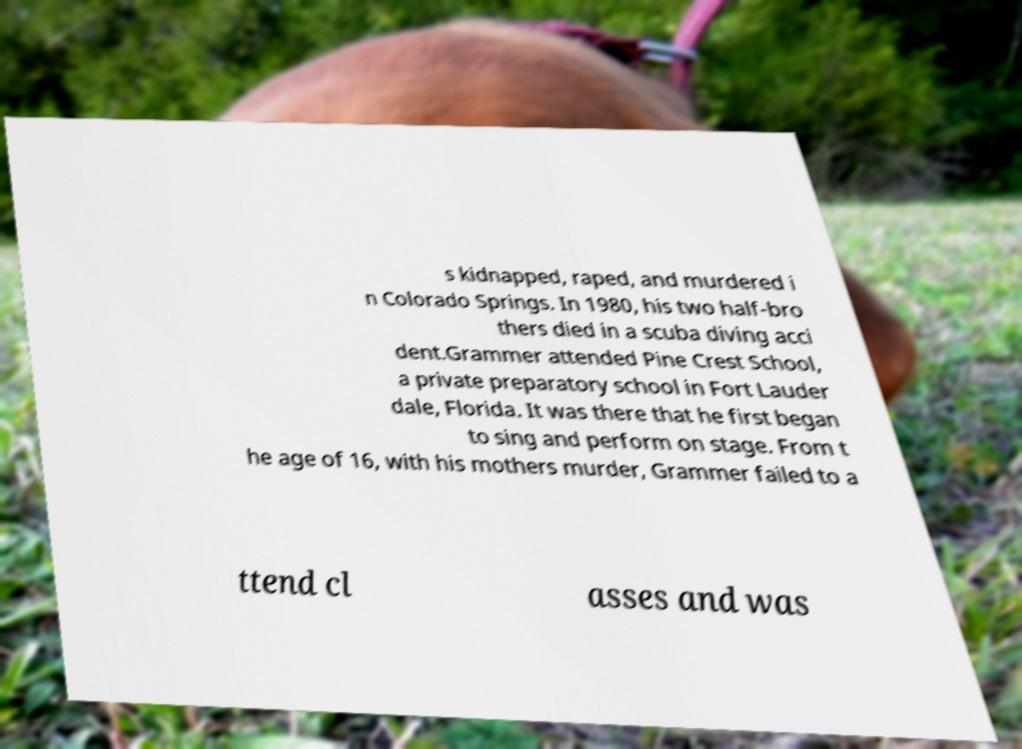There's text embedded in this image that I need extracted. Can you transcribe it verbatim? s kidnapped, raped, and murdered i n Colorado Springs. In 1980, his two half-bro thers died in a scuba diving acci dent.Grammer attended Pine Crest School, a private preparatory school in Fort Lauder dale, Florida. It was there that he first began to sing and perform on stage. From t he age of 16, with his mothers murder, Grammer failed to a ttend cl asses and was 